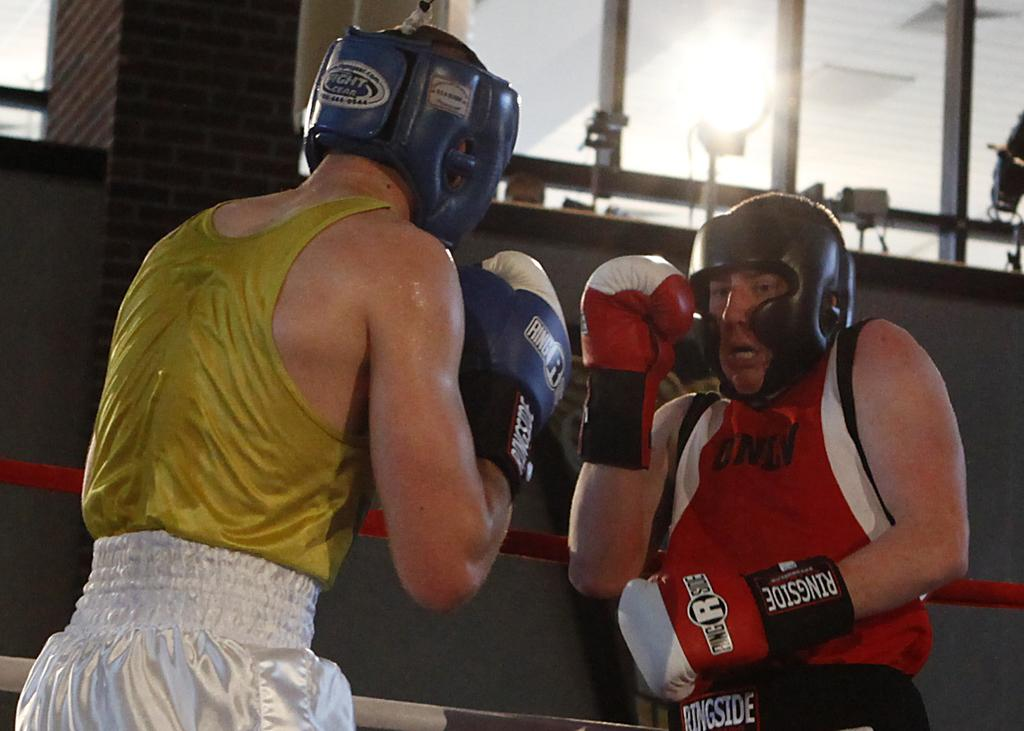<image>
Relay a brief, clear account of the picture shown. Two boxers are sparring on a ring with the logo for Ringside on the gloves. 